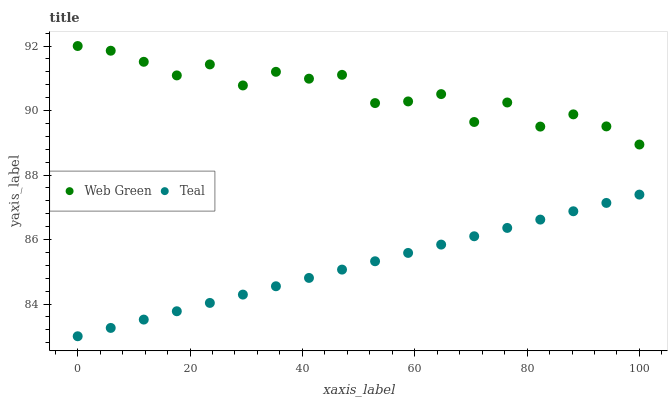Does Teal have the minimum area under the curve?
Answer yes or no. Yes. Does Web Green have the maximum area under the curve?
Answer yes or no. Yes. Does Web Green have the minimum area under the curve?
Answer yes or no. No. Is Teal the smoothest?
Answer yes or no. Yes. Is Web Green the roughest?
Answer yes or no. Yes. Is Web Green the smoothest?
Answer yes or no. No. Does Teal have the lowest value?
Answer yes or no. Yes. Does Web Green have the lowest value?
Answer yes or no. No. Does Web Green have the highest value?
Answer yes or no. Yes. Is Teal less than Web Green?
Answer yes or no. Yes. Is Web Green greater than Teal?
Answer yes or no. Yes. Does Teal intersect Web Green?
Answer yes or no. No. 